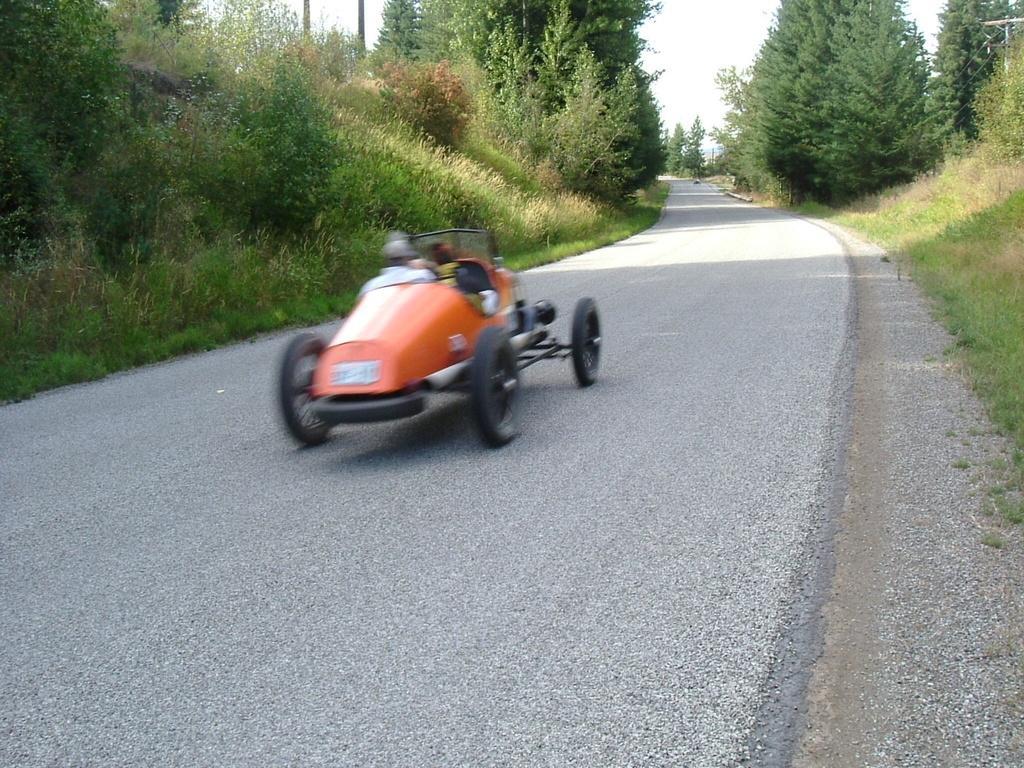Could you give a brief overview of what you see in this image? In this picture we can see vehicles are on the road, around we can see some trees and grass. 